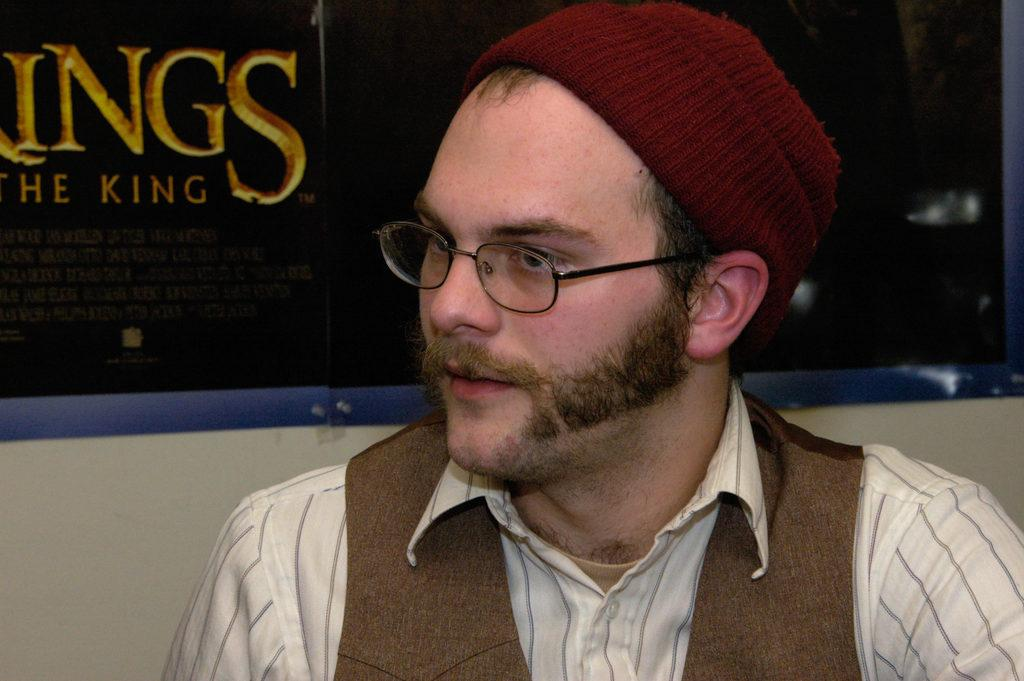What is the main subject of the image? There is a man in the image. Can you describe the man's appearance? The man is wearing spectacles, a cap, a shirt, and a jacket. What is visible behind the man in the image? There is a banner visible behind the man. What type of unit is the man operating in the image? There is no indication in the image that the man is operating a unit, as the facts provided do not mention any such activity. What is the man eating for lunch in the image? There is no food visible in the image, so it cannot be determined what the man might be eating for lunch. 